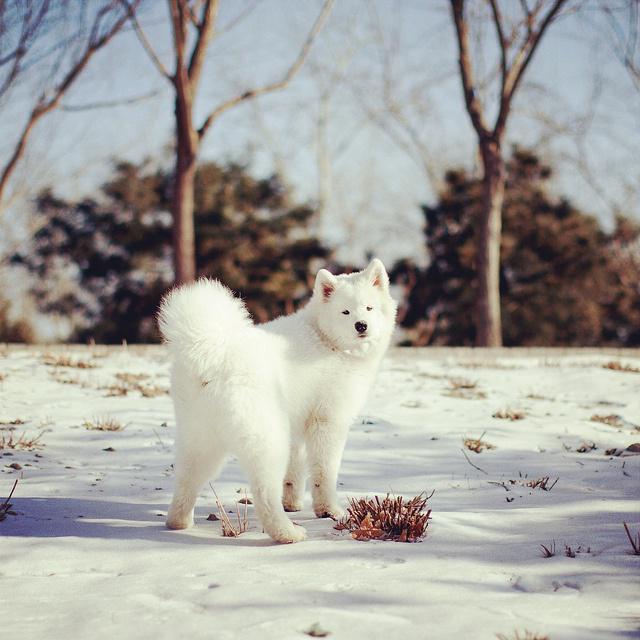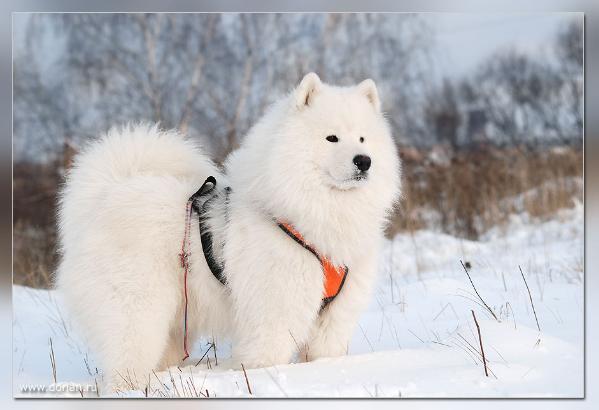The first image is the image on the left, the second image is the image on the right. For the images displayed, is the sentence "An image shows a white dog wearing a harness in a wintry scene." factually correct? Answer yes or no. Yes. The first image is the image on the left, the second image is the image on the right. Assess this claim about the two images: "Exactly two large white dogs are shown in snowy outdoor areas with trees in the background, one of them wearing a harness.". Correct or not? Answer yes or no. Yes. 